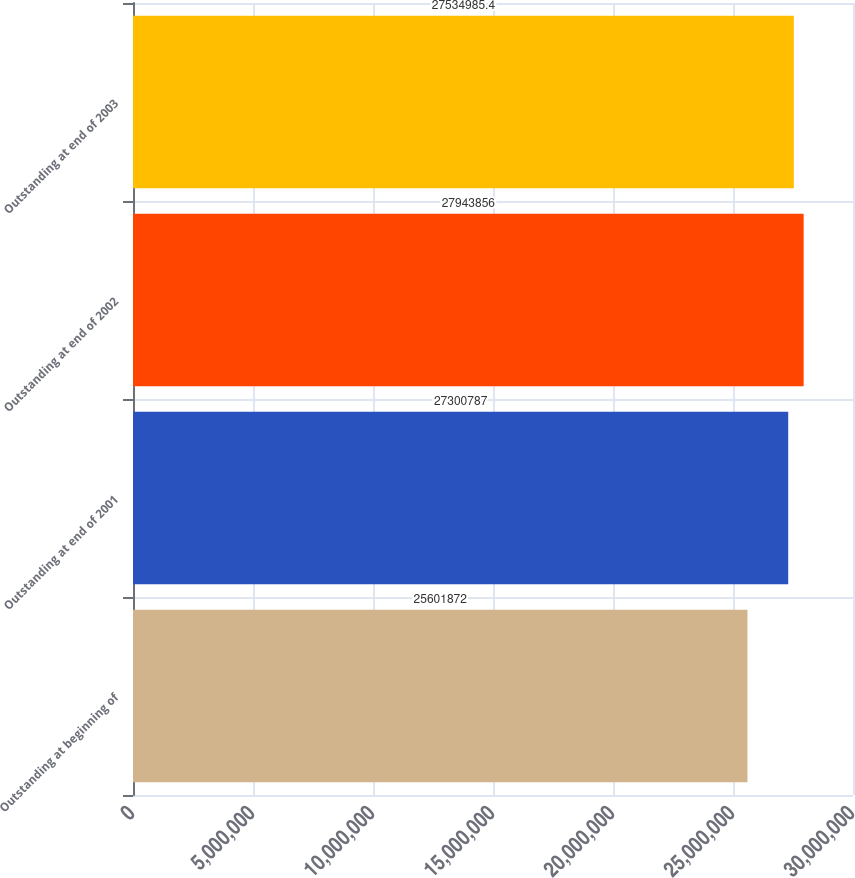<chart> <loc_0><loc_0><loc_500><loc_500><bar_chart><fcel>Outstanding at beginning of<fcel>Outstanding at end of 2001<fcel>Outstanding at end of 2002<fcel>Outstanding at end of 2003<nl><fcel>2.56019e+07<fcel>2.73008e+07<fcel>2.79439e+07<fcel>2.7535e+07<nl></chart> 